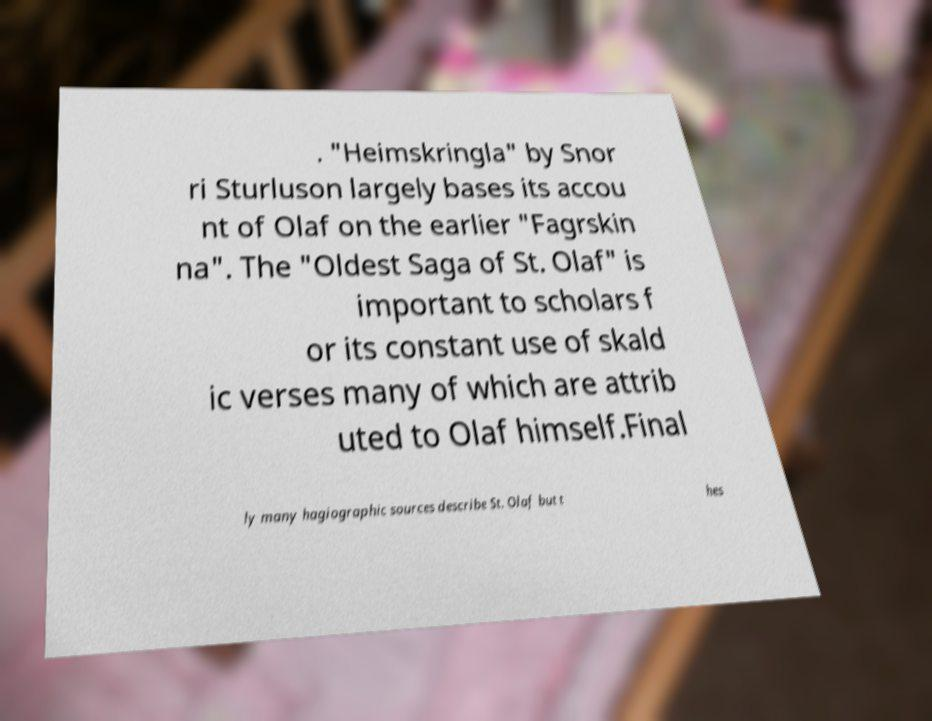Could you extract and type out the text from this image? . "Heimskringla" by Snor ri Sturluson largely bases its accou nt of Olaf on the earlier "Fagrskin na". The "Oldest Saga of St. Olaf" is important to scholars f or its constant use of skald ic verses many of which are attrib uted to Olaf himself.Final ly many hagiographic sources describe St. Olaf but t hes 